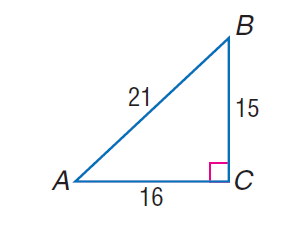Question: find \sin A.
Choices:
A. \frac { 5 } { 7 }
B. \frac { 16 } { 21 }
C. \frac { 15 } { 16 }
D. \frac { 16 } { 15 }
Answer with the letter. Answer: A Question: find \cos B.
Choices:
A. \frac { 5 } { 7 }
B. \frac { 16 } { 21 }
C. \frac { 15 } { 16 }
D. \frac { 16 } { 15 }
Answer with the letter. Answer: A Question: find \tan A.
Choices:
A. \frac { 15 } { 21 }
B. \frac { 16 } { 21 }
C. \frac { 15 } { 16 }
D. \frac { 16 } { 15 }
Answer with the letter. Answer: C 